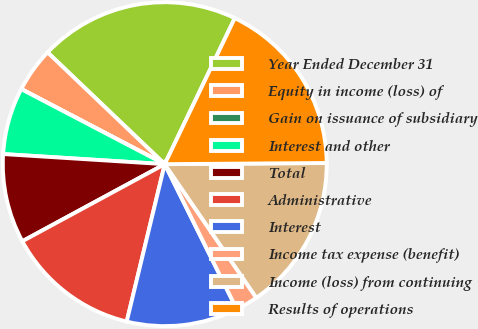<chart> <loc_0><loc_0><loc_500><loc_500><pie_chart><fcel>Year Ended December 31<fcel>Equity in income (loss) of<fcel>Gain on issuance of subsidiary<fcel>Interest and other<fcel>Total<fcel>Administrative<fcel>Interest<fcel>Income tax expense (benefit)<fcel>Income (loss) from continuing<fcel>Results of operations<nl><fcel>19.99%<fcel>4.45%<fcel>0.01%<fcel>6.67%<fcel>8.89%<fcel>13.33%<fcel>11.11%<fcel>2.23%<fcel>15.55%<fcel>17.77%<nl></chart> 